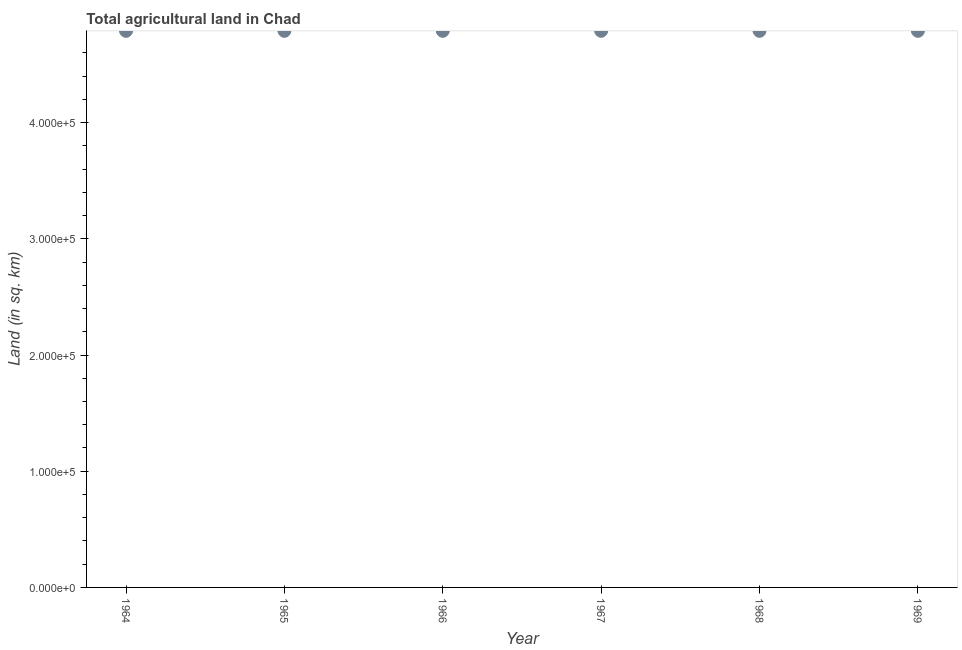What is the agricultural land in 1969?
Provide a succinct answer. 4.79e+05. Across all years, what is the maximum agricultural land?
Give a very brief answer. 4.79e+05. Across all years, what is the minimum agricultural land?
Make the answer very short. 4.79e+05. In which year was the agricultural land maximum?
Your response must be concise. 1964. In which year was the agricultural land minimum?
Offer a terse response. 1964. What is the sum of the agricultural land?
Offer a terse response. 2.87e+06. What is the difference between the agricultural land in 1966 and 1967?
Ensure brevity in your answer.  0. What is the average agricultural land per year?
Give a very brief answer. 4.79e+05. What is the median agricultural land?
Your answer should be very brief. 4.79e+05. In how many years, is the agricultural land greater than 440000 sq. km?
Provide a short and direct response. 6. Do a majority of the years between 1968 and 1965 (inclusive) have agricultural land greater than 360000 sq. km?
Keep it short and to the point. Yes. Is the agricultural land in 1965 less than that in 1966?
Provide a succinct answer. No. Is the difference between the agricultural land in 1967 and 1968 greater than the difference between any two years?
Your answer should be very brief. Yes. Does the agricultural land monotonically increase over the years?
Ensure brevity in your answer.  No. How many dotlines are there?
Your answer should be very brief. 1. How many years are there in the graph?
Your answer should be compact. 6. Does the graph contain grids?
Provide a short and direct response. No. What is the title of the graph?
Provide a short and direct response. Total agricultural land in Chad. What is the label or title of the Y-axis?
Your answer should be compact. Land (in sq. km). What is the Land (in sq. km) in 1964?
Your response must be concise. 4.79e+05. What is the Land (in sq. km) in 1965?
Provide a succinct answer. 4.79e+05. What is the Land (in sq. km) in 1966?
Your answer should be very brief. 4.79e+05. What is the Land (in sq. km) in 1967?
Your response must be concise. 4.79e+05. What is the Land (in sq. km) in 1968?
Make the answer very short. 4.79e+05. What is the Land (in sq. km) in 1969?
Ensure brevity in your answer.  4.79e+05. What is the difference between the Land (in sq. km) in 1964 and 1966?
Offer a very short reply. 0. What is the difference between the Land (in sq. km) in 1965 and 1966?
Give a very brief answer. 0. What is the difference between the Land (in sq. km) in 1965 and 1968?
Provide a succinct answer. 0. What is the difference between the Land (in sq. km) in 1965 and 1969?
Your response must be concise. 0. What is the difference between the Land (in sq. km) in 1966 and 1967?
Your answer should be compact. 0. What is the difference between the Land (in sq. km) in 1966 and 1969?
Offer a terse response. 0. What is the difference between the Land (in sq. km) in 1968 and 1969?
Provide a succinct answer. 0. What is the ratio of the Land (in sq. km) in 1964 to that in 1966?
Give a very brief answer. 1. What is the ratio of the Land (in sq. km) in 1964 to that in 1967?
Your response must be concise. 1. What is the ratio of the Land (in sq. km) in 1964 to that in 1969?
Your answer should be compact. 1. What is the ratio of the Land (in sq. km) in 1965 to that in 1966?
Your answer should be very brief. 1. What is the ratio of the Land (in sq. km) in 1965 to that in 1967?
Offer a very short reply. 1. What is the ratio of the Land (in sq. km) in 1965 to that in 1969?
Provide a short and direct response. 1. What is the ratio of the Land (in sq. km) in 1966 to that in 1968?
Offer a very short reply. 1. What is the ratio of the Land (in sq. km) in 1967 to that in 1968?
Provide a succinct answer. 1. What is the ratio of the Land (in sq. km) in 1967 to that in 1969?
Ensure brevity in your answer.  1. 